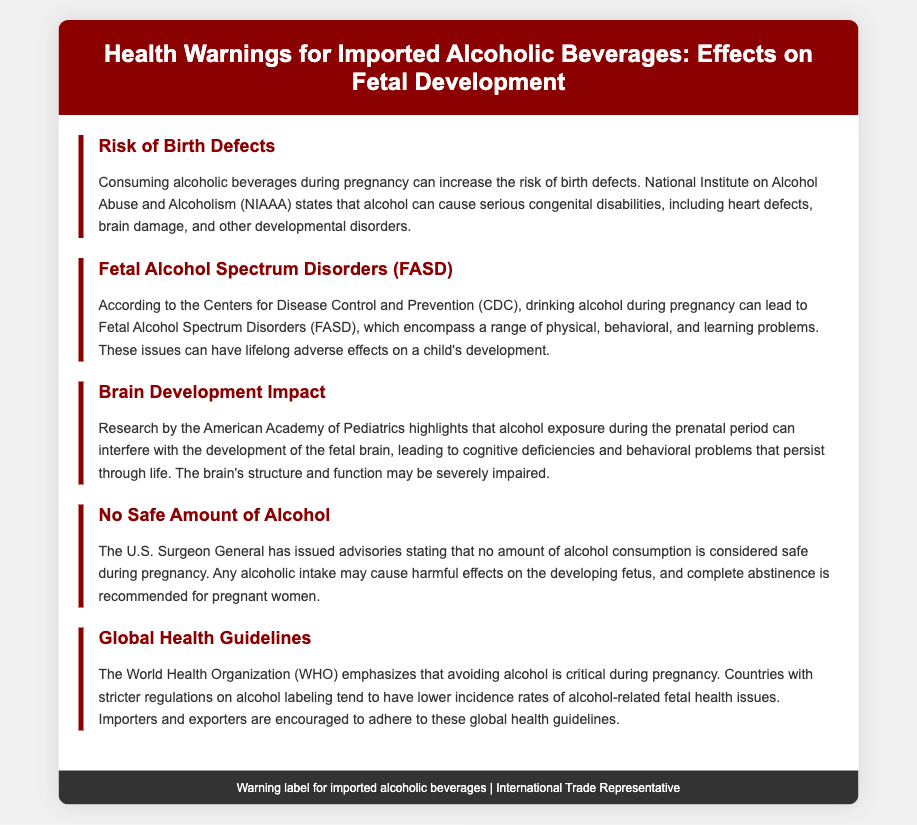What is the first risk mentioned? The first risk listed in the document is "Risk of Birth Defects," which refers to the potential for serious congenital disabilities due to alcohol consumption during pregnancy.
Answer: Risk of Birth Defects What organization states that no amount of alcohol is considered safe during pregnancy? The document mentions that the U.S. Surgeon General has issued advisories regarding alcohol consumption during pregnancy.
Answer: U.S. Surgeon General What disorders are included in Fetal Alcohol Spectrum Disorders? The document states that Fetal Alcohol Spectrum Disorders (FASD) encompass a range of physical, behavioral, and learning problems.
Answer: FASD Which organization emphasizes avoiding alcohol during pregnancy? The document indicates that the World Health Organization (WHO) emphasizes the importance of avoiding alcohol during pregnancy.
Answer: World Health Organization What type of problems can alcohol exposure interfere with according to the American Academy of Pediatrics? According to the American Academy of Pediatrics, alcohol exposure can interfere with the development of the fetal brain, leading to cognitive deficiencies and behavioral problems.
Answer: Brain development What is the overarching recommendation for pregnant women regarding alcohol consumption? The document provides a clear recommendation that complete abstinence from alcohol is advised for pregnant women.
Answer: Complete abstinence How does stricter regulation on alcohol labeling affect fetal health issues? The document states that countries with stricter regulations on alcohol labeling tend to have lower incidence rates of alcohol-related fetal health issues.
Answer: Lower incidence rates Which health guideline mentions the impact of prenatal alcohol exposure? The American Academy of Pediatrics highlights the impact of prenatal alcohol exposure on brain development.
Answer: American Academy of Pediatrics 